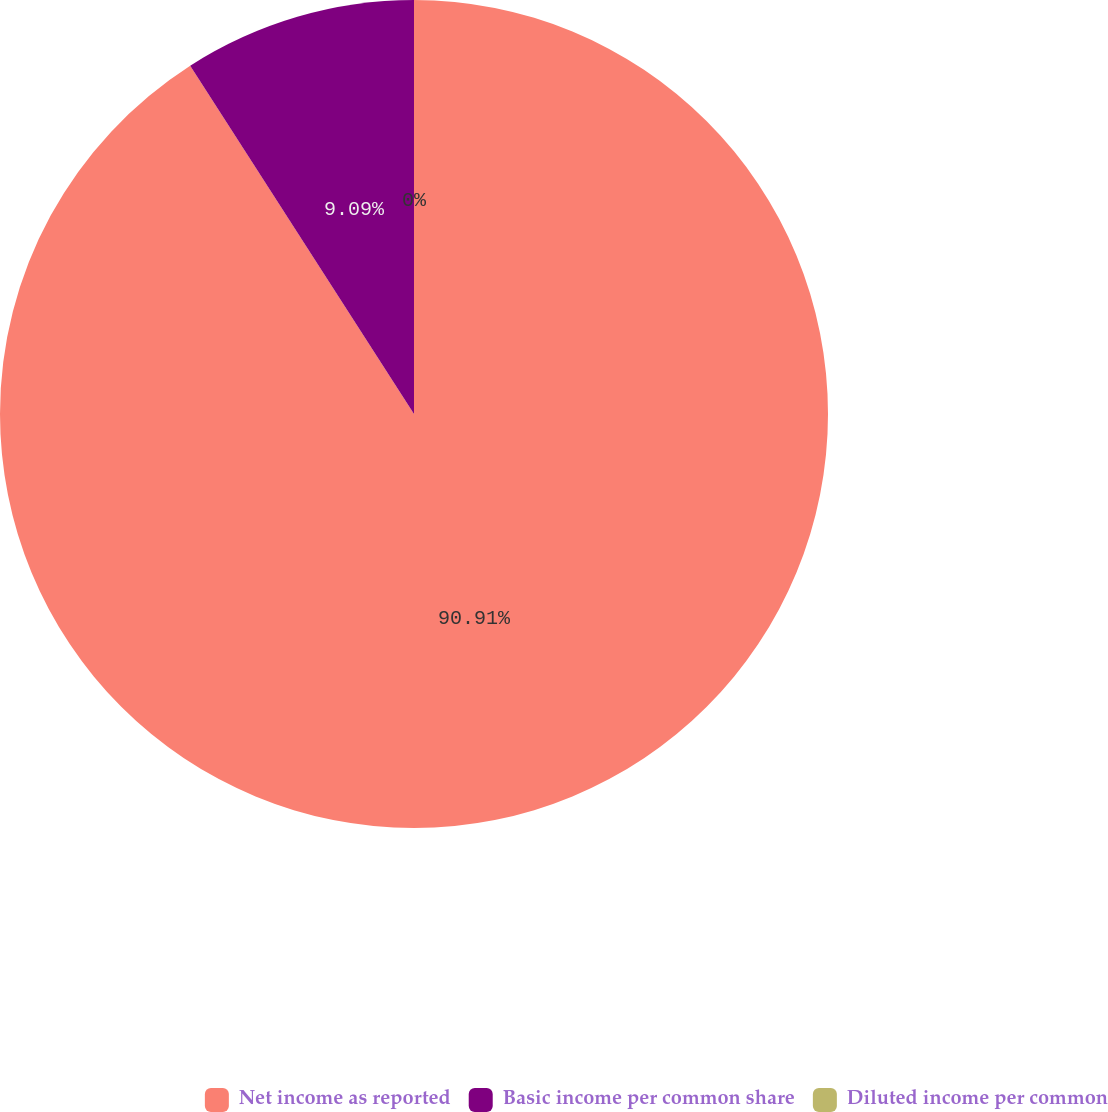Convert chart to OTSL. <chart><loc_0><loc_0><loc_500><loc_500><pie_chart><fcel>Net income as reported<fcel>Basic income per common share<fcel>Diluted income per common<nl><fcel>90.91%<fcel>9.09%<fcel>0.0%<nl></chart> 